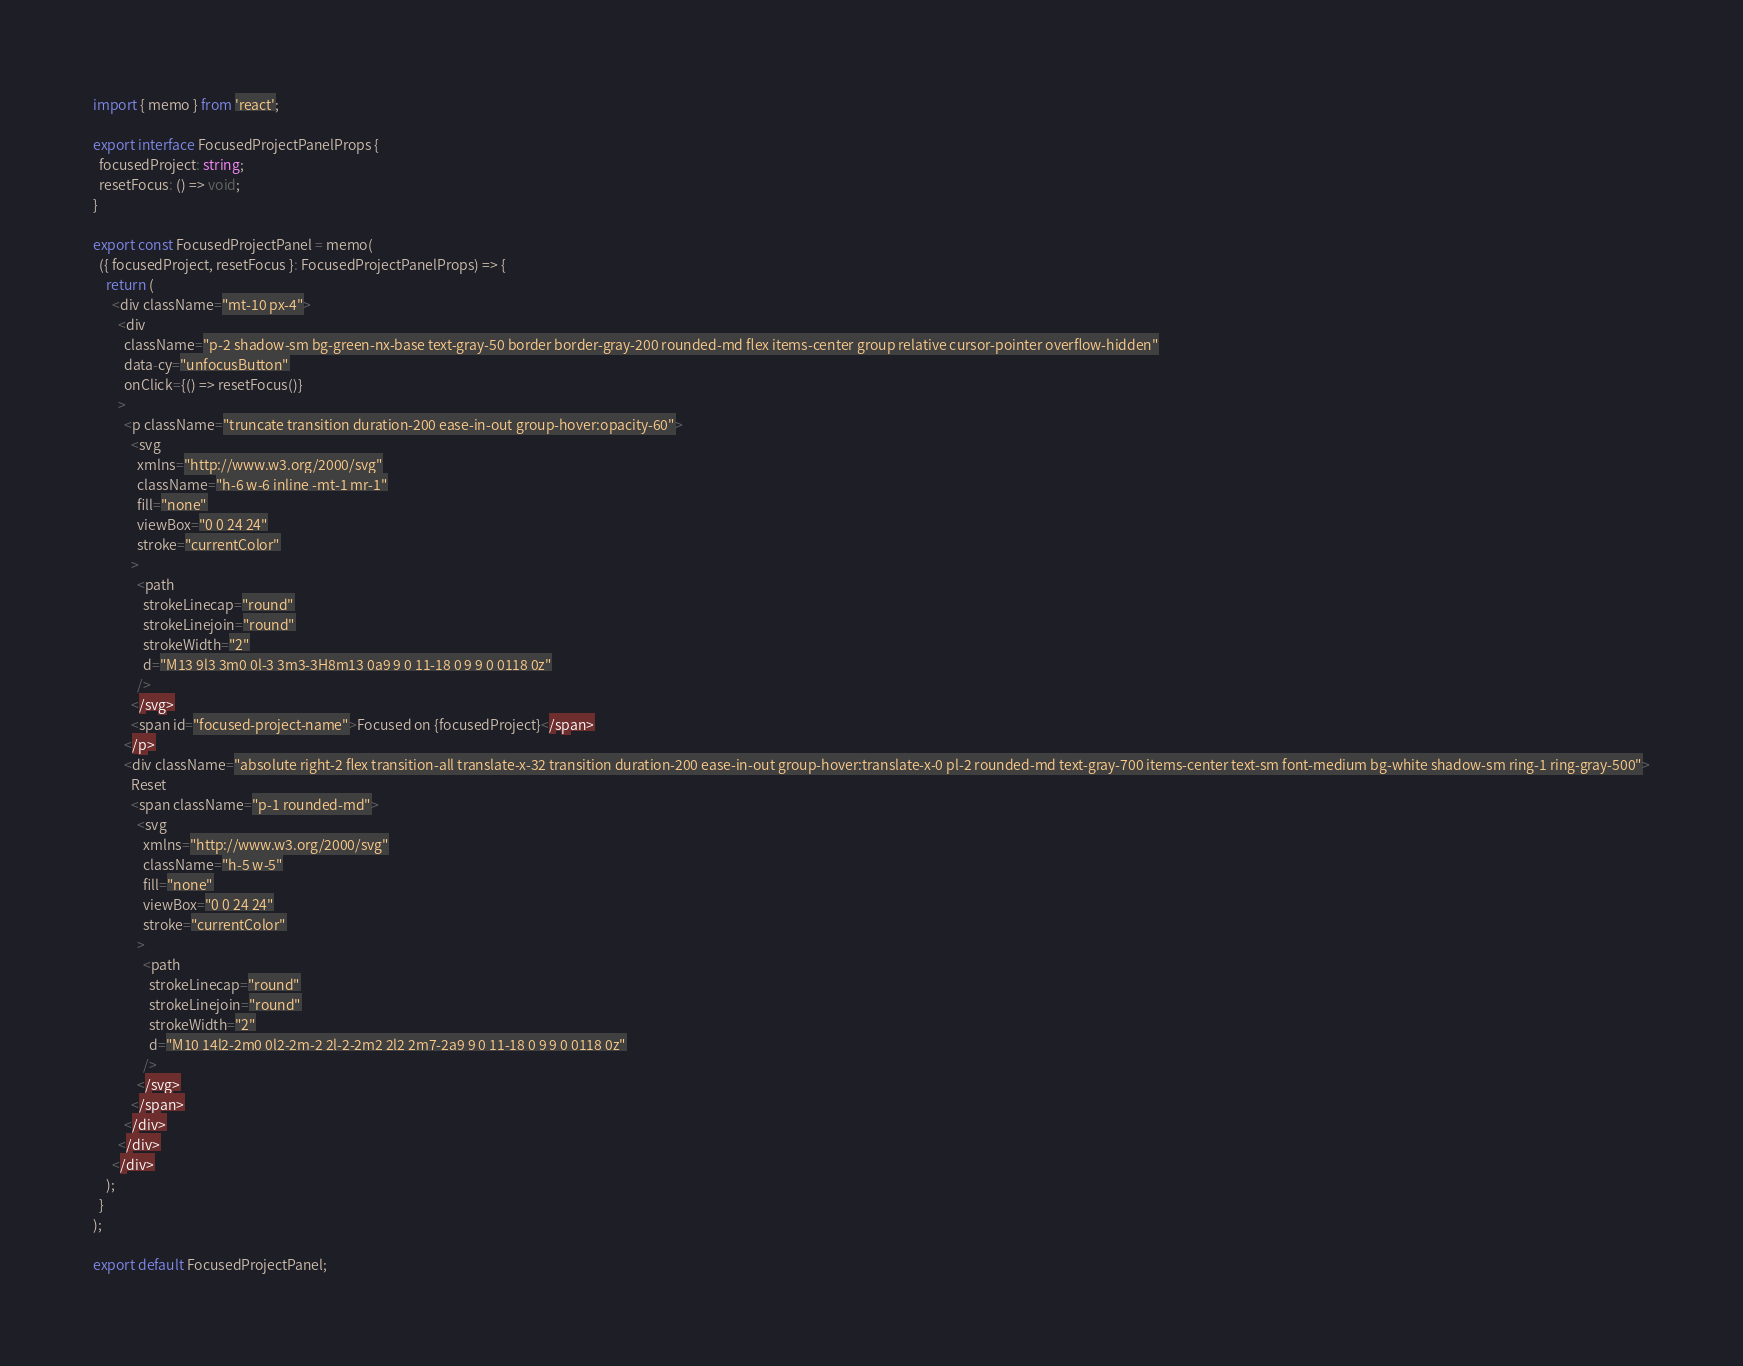<code> <loc_0><loc_0><loc_500><loc_500><_TypeScript_>import { memo } from 'react';

export interface FocusedProjectPanelProps {
  focusedProject: string;
  resetFocus: () => void;
}

export const FocusedProjectPanel = memo(
  ({ focusedProject, resetFocus }: FocusedProjectPanelProps) => {
    return (
      <div className="mt-10 px-4">
        <div
          className="p-2 shadow-sm bg-green-nx-base text-gray-50 border border-gray-200 rounded-md flex items-center group relative cursor-pointer overflow-hidden"
          data-cy="unfocusButton"
          onClick={() => resetFocus()}
        >
          <p className="truncate transition duration-200 ease-in-out group-hover:opacity-60">
            <svg
              xmlns="http://www.w3.org/2000/svg"
              className="h-6 w-6 inline -mt-1 mr-1"
              fill="none"
              viewBox="0 0 24 24"
              stroke="currentColor"
            >
              <path
                strokeLinecap="round"
                strokeLinejoin="round"
                strokeWidth="2"
                d="M13 9l3 3m0 0l-3 3m3-3H8m13 0a9 9 0 11-18 0 9 9 0 0118 0z"
              />
            </svg>
            <span id="focused-project-name">Focused on {focusedProject}</span>
          </p>
          <div className="absolute right-2 flex transition-all translate-x-32 transition duration-200 ease-in-out group-hover:translate-x-0 pl-2 rounded-md text-gray-700 items-center text-sm font-medium bg-white shadow-sm ring-1 ring-gray-500">
            Reset
            <span className="p-1 rounded-md">
              <svg
                xmlns="http://www.w3.org/2000/svg"
                className="h-5 w-5"
                fill="none"
                viewBox="0 0 24 24"
                stroke="currentColor"
              >
                <path
                  strokeLinecap="round"
                  strokeLinejoin="round"
                  strokeWidth="2"
                  d="M10 14l2-2m0 0l2-2m-2 2l-2-2m2 2l2 2m7-2a9 9 0 11-18 0 9 9 0 0118 0z"
                />
              </svg>
            </span>
          </div>
        </div>
      </div>
    );
  }
);

export default FocusedProjectPanel;
</code> 